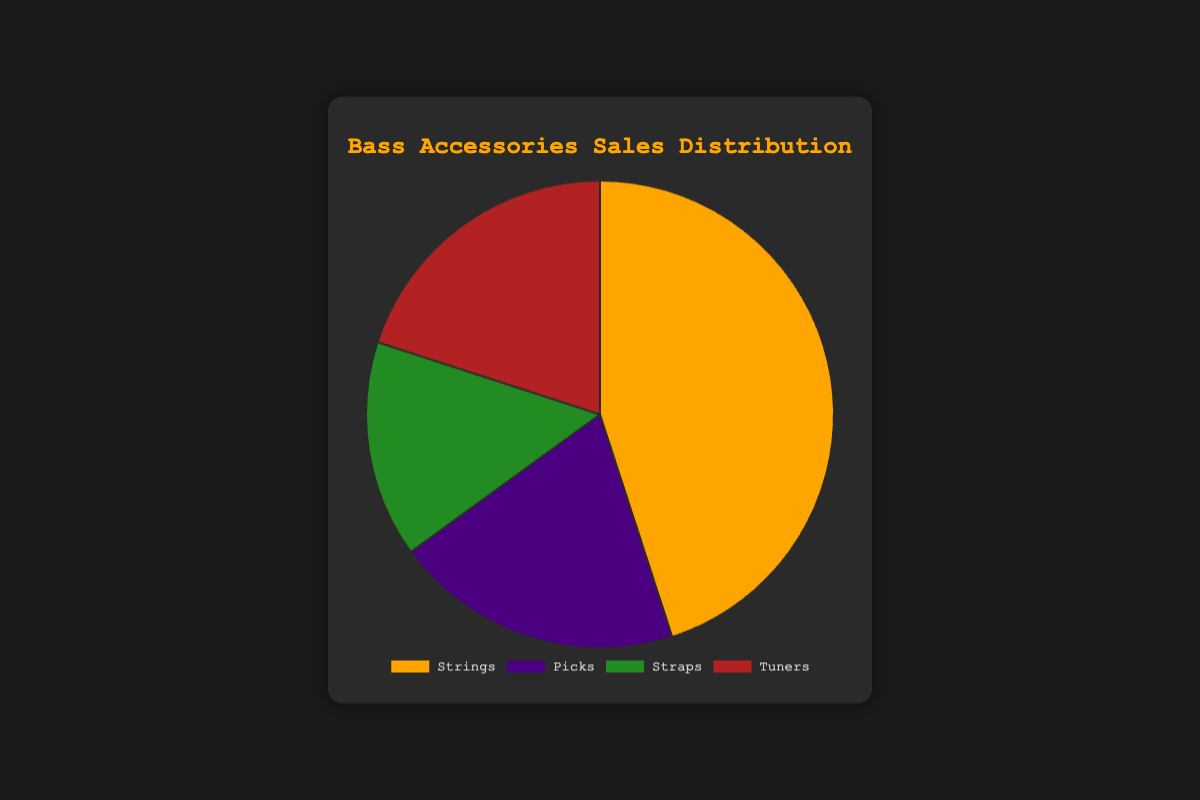What percentage of total sales do Strings, Picks, and Straps together account for? Summing the sales data for Strings, Picks, and Straps: 45 (Strings) + 20 (Picks) + 15 (Straps) = 80. Total sales across all items = 100. So, the percentage is (80 / 100) * 100% = 80%.
Answer: 80% Which accessory type has the highest sales? By looking at the pie chart, you can see that Strings have the largest slice, indicating the highest sales.
Answer: Strings Are sales of Picks and Tuners equal? According to the legend in the pie chart, both Picks and Tuners have a sales value of 20. So yes, they are equal.
Answer: Yes What is the sales difference between Strings and Tuners? The sales for Strings is 45 and for Tuners, it's 20. The difference is 45 - 20 = 25.
Answer: 25 How much more in percentage terms are the sales of Strings compared to Straps? The sales of Strings is 45 and for Straps, it's 15. The percentage increase is given by [(45 - 15) / 15] * 100% = 200%.
Answer: 200% If sales of Tuners increased by 10 units, which accessory type would have the highest sales? Increase Tuners' sales from 20 to 30. Strings still have the highest sales at 45, so Strings would remain the highest.
Answer: Strings What's the average sales value of all the accessory types? The total sales sum is 45 (Strings) + 20 (Picks) + 15 (Straps) + 20 (Tuners) = 100. There are 4 types of accessories, so the mean is 100 / 4 = 25.
Answer: 25 What is the combined sales value of the accessory types represented by green and red portions? Based on the color legend, Straps are green (15) and Tuners are red (20). Their combined sales value is 15 + 20 = 35.
Answer: 35 